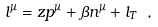Convert formula to latex. <formula><loc_0><loc_0><loc_500><loc_500>l ^ { \mu } = z p ^ { \mu } + \beta n ^ { \mu } + l _ { T } \ ,</formula> 